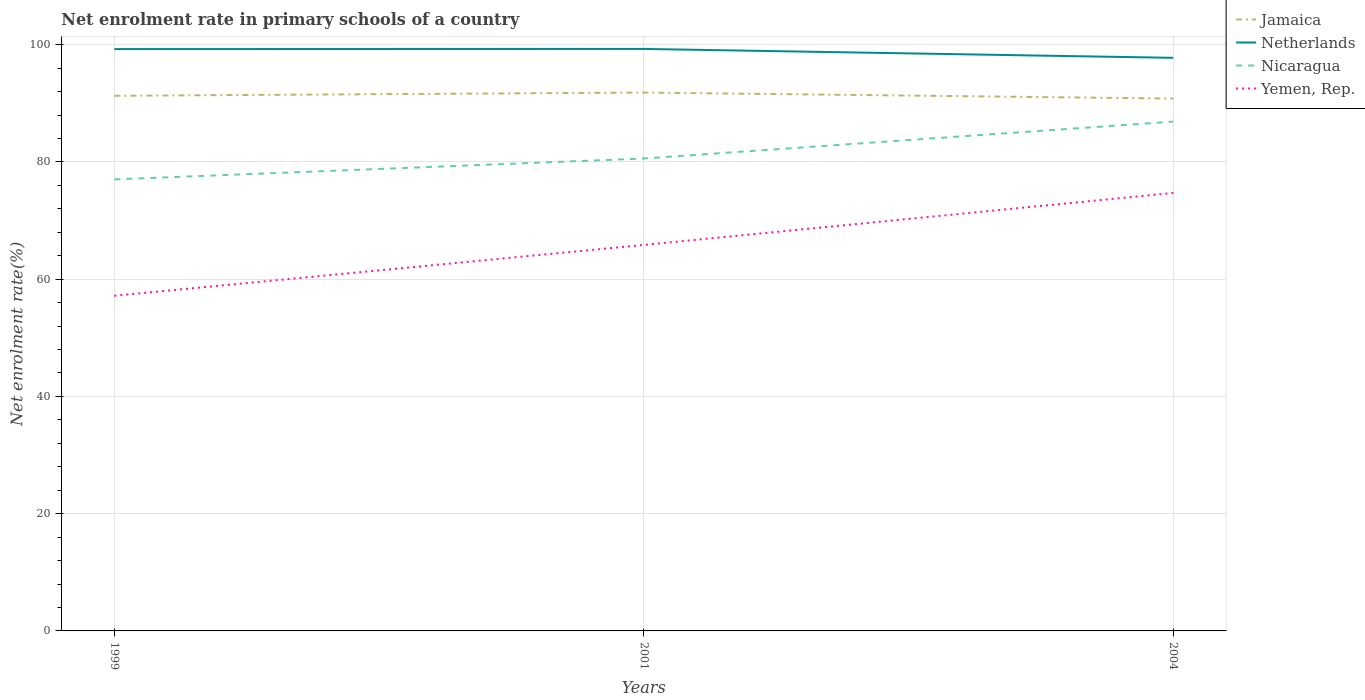Is the number of lines equal to the number of legend labels?
Offer a very short reply. Yes. Across all years, what is the maximum net enrolment rate in primary schools in Yemen, Rep.?
Provide a succinct answer. 57.17. What is the total net enrolment rate in primary schools in Netherlands in the graph?
Keep it short and to the point. 1.52. What is the difference between the highest and the second highest net enrolment rate in primary schools in Nicaragua?
Ensure brevity in your answer.  9.86. How many years are there in the graph?
Offer a terse response. 3. Are the values on the major ticks of Y-axis written in scientific E-notation?
Make the answer very short. No. Where does the legend appear in the graph?
Provide a short and direct response. Top right. How are the legend labels stacked?
Ensure brevity in your answer.  Vertical. What is the title of the graph?
Keep it short and to the point. Net enrolment rate in primary schools of a country. What is the label or title of the X-axis?
Ensure brevity in your answer.  Years. What is the label or title of the Y-axis?
Offer a very short reply. Net enrolment rate(%). What is the Net enrolment rate(%) in Jamaica in 1999?
Keep it short and to the point. 91.28. What is the Net enrolment rate(%) of Netherlands in 1999?
Offer a very short reply. 99.25. What is the Net enrolment rate(%) of Nicaragua in 1999?
Your response must be concise. 77.02. What is the Net enrolment rate(%) of Yemen, Rep. in 1999?
Your answer should be compact. 57.17. What is the Net enrolment rate(%) in Jamaica in 2001?
Provide a succinct answer. 91.83. What is the Net enrolment rate(%) in Netherlands in 2001?
Your answer should be very brief. 99.28. What is the Net enrolment rate(%) of Nicaragua in 2001?
Keep it short and to the point. 80.58. What is the Net enrolment rate(%) of Yemen, Rep. in 2001?
Ensure brevity in your answer.  65.84. What is the Net enrolment rate(%) of Jamaica in 2004?
Ensure brevity in your answer.  90.81. What is the Net enrolment rate(%) of Netherlands in 2004?
Give a very brief answer. 97.76. What is the Net enrolment rate(%) of Nicaragua in 2004?
Offer a terse response. 86.88. What is the Net enrolment rate(%) in Yemen, Rep. in 2004?
Provide a short and direct response. 74.71. Across all years, what is the maximum Net enrolment rate(%) in Jamaica?
Ensure brevity in your answer.  91.83. Across all years, what is the maximum Net enrolment rate(%) of Netherlands?
Ensure brevity in your answer.  99.28. Across all years, what is the maximum Net enrolment rate(%) of Nicaragua?
Keep it short and to the point. 86.88. Across all years, what is the maximum Net enrolment rate(%) of Yemen, Rep.?
Give a very brief answer. 74.71. Across all years, what is the minimum Net enrolment rate(%) in Jamaica?
Offer a very short reply. 90.81. Across all years, what is the minimum Net enrolment rate(%) of Netherlands?
Ensure brevity in your answer.  97.76. Across all years, what is the minimum Net enrolment rate(%) in Nicaragua?
Keep it short and to the point. 77.02. Across all years, what is the minimum Net enrolment rate(%) of Yemen, Rep.?
Your response must be concise. 57.17. What is the total Net enrolment rate(%) of Jamaica in the graph?
Give a very brief answer. 273.92. What is the total Net enrolment rate(%) of Netherlands in the graph?
Ensure brevity in your answer.  296.28. What is the total Net enrolment rate(%) of Nicaragua in the graph?
Ensure brevity in your answer.  244.48. What is the total Net enrolment rate(%) of Yemen, Rep. in the graph?
Give a very brief answer. 197.73. What is the difference between the Net enrolment rate(%) in Jamaica in 1999 and that in 2001?
Provide a succinct answer. -0.55. What is the difference between the Net enrolment rate(%) in Netherlands in 1999 and that in 2001?
Make the answer very short. -0.03. What is the difference between the Net enrolment rate(%) in Nicaragua in 1999 and that in 2001?
Offer a terse response. -3.57. What is the difference between the Net enrolment rate(%) in Yemen, Rep. in 1999 and that in 2001?
Give a very brief answer. -8.67. What is the difference between the Net enrolment rate(%) of Jamaica in 1999 and that in 2004?
Make the answer very short. 0.47. What is the difference between the Net enrolment rate(%) of Netherlands in 1999 and that in 2004?
Make the answer very short. 1.49. What is the difference between the Net enrolment rate(%) in Nicaragua in 1999 and that in 2004?
Give a very brief answer. -9.86. What is the difference between the Net enrolment rate(%) in Yemen, Rep. in 1999 and that in 2004?
Make the answer very short. -17.54. What is the difference between the Net enrolment rate(%) of Jamaica in 2001 and that in 2004?
Make the answer very short. 1.03. What is the difference between the Net enrolment rate(%) of Netherlands in 2001 and that in 2004?
Keep it short and to the point. 1.52. What is the difference between the Net enrolment rate(%) in Nicaragua in 2001 and that in 2004?
Offer a terse response. -6.3. What is the difference between the Net enrolment rate(%) of Yemen, Rep. in 2001 and that in 2004?
Ensure brevity in your answer.  -8.87. What is the difference between the Net enrolment rate(%) of Jamaica in 1999 and the Net enrolment rate(%) of Netherlands in 2001?
Offer a very short reply. -7.99. What is the difference between the Net enrolment rate(%) of Jamaica in 1999 and the Net enrolment rate(%) of Nicaragua in 2001?
Ensure brevity in your answer.  10.7. What is the difference between the Net enrolment rate(%) in Jamaica in 1999 and the Net enrolment rate(%) in Yemen, Rep. in 2001?
Make the answer very short. 25.44. What is the difference between the Net enrolment rate(%) of Netherlands in 1999 and the Net enrolment rate(%) of Nicaragua in 2001?
Provide a short and direct response. 18.66. What is the difference between the Net enrolment rate(%) of Netherlands in 1999 and the Net enrolment rate(%) of Yemen, Rep. in 2001?
Your answer should be very brief. 33.41. What is the difference between the Net enrolment rate(%) in Nicaragua in 1999 and the Net enrolment rate(%) in Yemen, Rep. in 2001?
Offer a very short reply. 11.18. What is the difference between the Net enrolment rate(%) of Jamaica in 1999 and the Net enrolment rate(%) of Netherlands in 2004?
Ensure brevity in your answer.  -6.48. What is the difference between the Net enrolment rate(%) in Jamaica in 1999 and the Net enrolment rate(%) in Nicaragua in 2004?
Give a very brief answer. 4.4. What is the difference between the Net enrolment rate(%) in Jamaica in 1999 and the Net enrolment rate(%) in Yemen, Rep. in 2004?
Your answer should be compact. 16.57. What is the difference between the Net enrolment rate(%) of Netherlands in 1999 and the Net enrolment rate(%) of Nicaragua in 2004?
Your response must be concise. 12.37. What is the difference between the Net enrolment rate(%) in Netherlands in 1999 and the Net enrolment rate(%) in Yemen, Rep. in 2004?
Offer a terse response. 24.53. What is the difference between the Net enrolment rate(%) in Nicaragua in 1999 and the Net enrolment rate(%) in Yemen, Rep. in 2004?
Provide a succinct answer. 2.3. What is the difference between the Net enrolment rate(%) in Jamaica in 2001 and the Net enrolment rate(%) in Netherlands in 2004?
Provide a short and direct response. -5.92. What is the difference between the Net enrolment rate(%) of Jamaica in 2001 and the Net enrolment rate(%) of Nicaragua in 2004?
Give a very brief answer. 4.95. What is the difference between the Net enrolment rate(%) of Jamaica in 2001 and the Net enrolment rate(%) of Yemen, Rep. in 2004?
Your response must be concise. 17.12. What is the difference between the Net enrolment rate(%) in Netherlands in 2001 and the Net enrolment rate(%) in Nicaragua in 2004?
Give a very brief answer. 12.39. What is the difference between the Net enrolment rate(%) of Netherlands in 2001 and the Net enrolment rate(%) of Yemen, Rep. in 2004?
Your response must be concise. 24.56. What is the difference between the Net enrolment rate(%) in Nicaragua in 2001 and the Net enrolment rate(%) in Yemen, Rep. in 2004?
Offer a terse response. 5.87. What is the average Net enrolment rate(%) of Jamaica per year?
Your response must be concise. 91.31. What is the average Net enrolment rate(%) in Netherlands per year?
Your response must be concise. 98.76. What is the average Net enrolment rate(%) of Nicaragua per year?
Offer a terse response. 81.49. What is the average Net enrolment rate(%) in Yemen, Rep. per year?
Provide a short and direct response. 65.91. In the year 1999, what is the difference between the Net enrolment rate(%) in Jamaica and Net enrolment rate(%) in Netherlands?
Give a very brief answer. -7.97. In the year 1999, what is the difference between the Net enrolment rate(%) of Jamaica and Net enrolment rate(%) of Nicaragua?
Offer a terse response. 14.26. In the year 1999, what is the difference between the Net enrolment rate(%) of Jamaica and Net enrolment rate(%) of Yemen, Rep.?
Your response must be concise. 34.11. In the year 1999, what is the difference between the Net enrolment rate(%) in Netherlands and Net enrolment rate(%) in Nicaragua?
Your answer should be very brief. 22.23. In the year 1999, what is the difference between the Net enrolment rate(%) of Netherlands and Net enrolment rate(%) of Yemen, Rep.?
Your answer should be compact. 42.08. In the year 1999, what is the difference between the Net enrolment rate(%) in Nicaragua and Net enrolment rate(%) in Yemen, Rep.?
Offer a very short reply. 19.85. In the year 2001, what is the difference between the Net enrolment rate(%) in Jamaica and Net enrolment rate(%) in Netherlands?
Offer a very short reply. -7.44. In the year 2001, what is the difference between the Net enrolment rate(%) in Jamaica and Net enrolment rate(%) in Nicaragua?
Offer a terse response. 11.25. In the year 2001, what is the difference between the Net enrolment rate(%) of Jamaica and Net enrolment rate(%) of Yemen, Rep.?
Provide a short and direct response. 25.99. In the year 2001, what is the difference between the Net enrolment rate(%) in Netherlands and Net enrolment rate(%) in Nicaragua?
Keep it short and to the point. 18.69. In the year 2001, what is the difference between the Net enrolment rate(%) in Netherlands and Net enrolment rate(%) in Yemen, Rep.?
Provide a short and direct response. 33.43. In the year 2001, what is the difference between the Net enrolment rate(%) in Nicaragua and Net enrolment rate(%) in Yemen, Rep.?
Give a very brief answer. 14.74. In the year 2004, what is the difference between the Net enrolment rate(%) in Jamaica and Net enrolment rate(%) in Netherlands?
Provide a short and direct response. -6.95. In the year 2004, what is the difference between the Net enrolment rate(%) of Jamaica and Net enrolment rate(%) of Nicaragua?
Give a very brief answer. 3.93. In the year 2004, what is the difference between the Net enrolment rate(%) of Jamaica and Net enrolment rate(%) of Yemen, Rep.?
Make the answer very short. 16.09. In the year 2004, what is the difference between the Net enrolment rate(%) of Netherlands and Net enrolment rate(%) of Nicaragua?
Offer a very short reply. 10.88. In the year 2004, what is the difference between the Net enrolment rate(%) in Netherlands and Net enrolment rate(%) in Yemen, Rep.?
Your response must be concise. 23.04. In the year 2004, what is the difference between the Net enrolment rate(%) of Nicaragua and Net enrolment rate(%) of Yemen, Rep.?
Ensure brevity in your answer.  12.17. What is the ratio of the Net enrolment rate(%) of Jamaica in 1999 to that in 2001?
Your answer should be very brief. 0.99. What is the ratio of the Net enrolment rate(%) in Nicaragua in 1999 to that in 2001?
Keep it short and to the point. 0.96. What is the ratio of the Net enrolment rate(%) of Yemen, Rep. in 1999 to that in 2001?
Your response must be concise. 0.87. What is the ratio of the Net enrolment rate(%) in Jamaica in 1999 to that in 2004?
Make the answer very short. 1.01. What is the ratio of the Net enrolment rate(%) in Netherlands in 1999 to that in 2004?
Ensure brevity in your answer.  1.02. What is the ratio of the Net enrolment rate(%) in Nicaragua in 1999 to that in 2004?
Provide a short and direct response. 0.89. What is the ratio of the Net enrolment rate(%) in Yemen, Rep. in 1999 to that in 2004?
Make the answer very short. 0.77. What is the ratio of the Net enrolment rate(%) in Jamaica in 2001 to that in 2004?
Give a very brief answer. 1.01. What is the ratio of the Net enrolment rate(%) in Netherlands in 2001 to that in 2004?
Keep it short and to the point. 1.02. What is the ratio of the Net enrolment rate(%) of Nicaragua in 2001 to that in 2004?
Your response must be concise. 0.93. What is the ratio of the Net enrolment rate(%) in Yemen, Rep. in 2001 to that in 2004?
Give a very brief answer. 0.88. What is the difference between the highest and the second highest Net enrolment rate(%) in Jamaica?
Your answer should be very brief. 0.55. What is the difference between the highest and the second highest Net enrolment rate(%) of Netherlands?
Your answer should be compact. 0.03. What is the difference between the highest and the second highest Net enrolment rate(%) of Nicaragua?
Give a very brief answer. 6.3. What is the difference between the highest and the second highest Net enrolment rate(%) of Yemen, Rep.?
Provide a short and direct response. 8.87. What is the difference between the highest and the lowest Net enrolment rate(%) of Jamaica?
Offer a terse response. 1.03. What is the difference between the highest and the lowest Net enrolment rate(%) in Netherlands?
Give a very brief answer. 1.52. What is the difference between the highest and the lowest Net enrolment rate(%) of Nicaragua?
Provide a succinct answer. 9.86. What is the difference between the highest and the lowest Net enrolment rate(%) of Yemen, Rep.?
Provide a short and direct response. 17.54. 